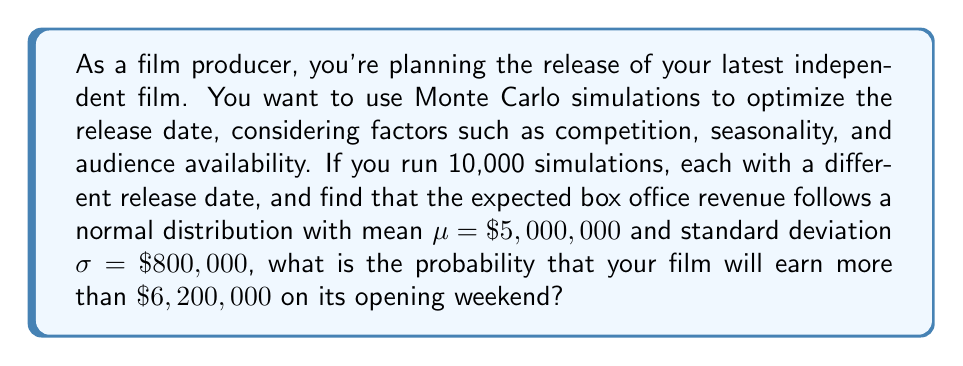Show me your answer to this math problem. To solve this problem, we'll use the properties of the normal distribution and the concept of z-scores:

1) First, we need to calculate the z-score for the target value ($\$6,200,000$):

   $z = \frac{x - \mu}{\sigma}$

   Where:
   $x = \$6,200,000$ (target value)
   $\mu = \$5,000,000$ (mean)
   $\sigma = \$800,000$ (standard deviation)

2) Plugging in the values:

   $z = \frac{6,200,000 - 5,000,000}{800,000} = \frac{1,200,000}{800,000} = 1.5$

3) Now that we have the z-score, we need to find the probability of a value being greater than this z-score. In a standard normal distribution, this is equivalent to finding the area to the right of z = 1.5.

4) Using a standard normal distribution table or a calculator with this function, we can find that:

   $P(Z > 1.5) \approx 0.0668$

5) Therefore, the probability of earning more than $\$6,200,000$ is approximately 0.0668 or 6.68%.
Answer: 0.0668 (or 6.68%) 